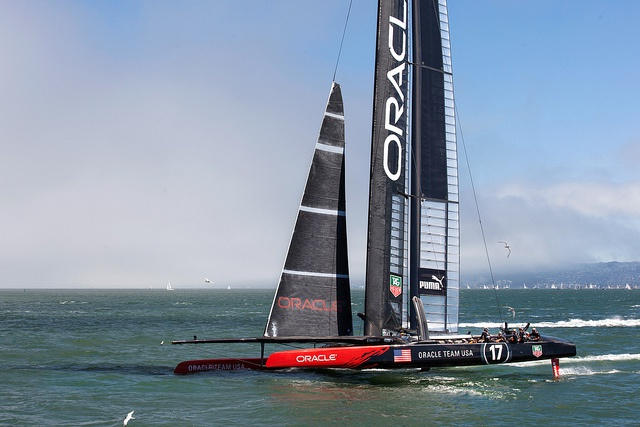Describe the objects in this image and their specific colors. I can see boat in darkgray, black, gray, and lightgray tones, people in darkgray, black, gray, and brown tones, people in darkgray, gray, and black tones, people in darkgray, black, gray, and maroon tones, and people in darkgray, black, maroon, and gray tones in this image. 